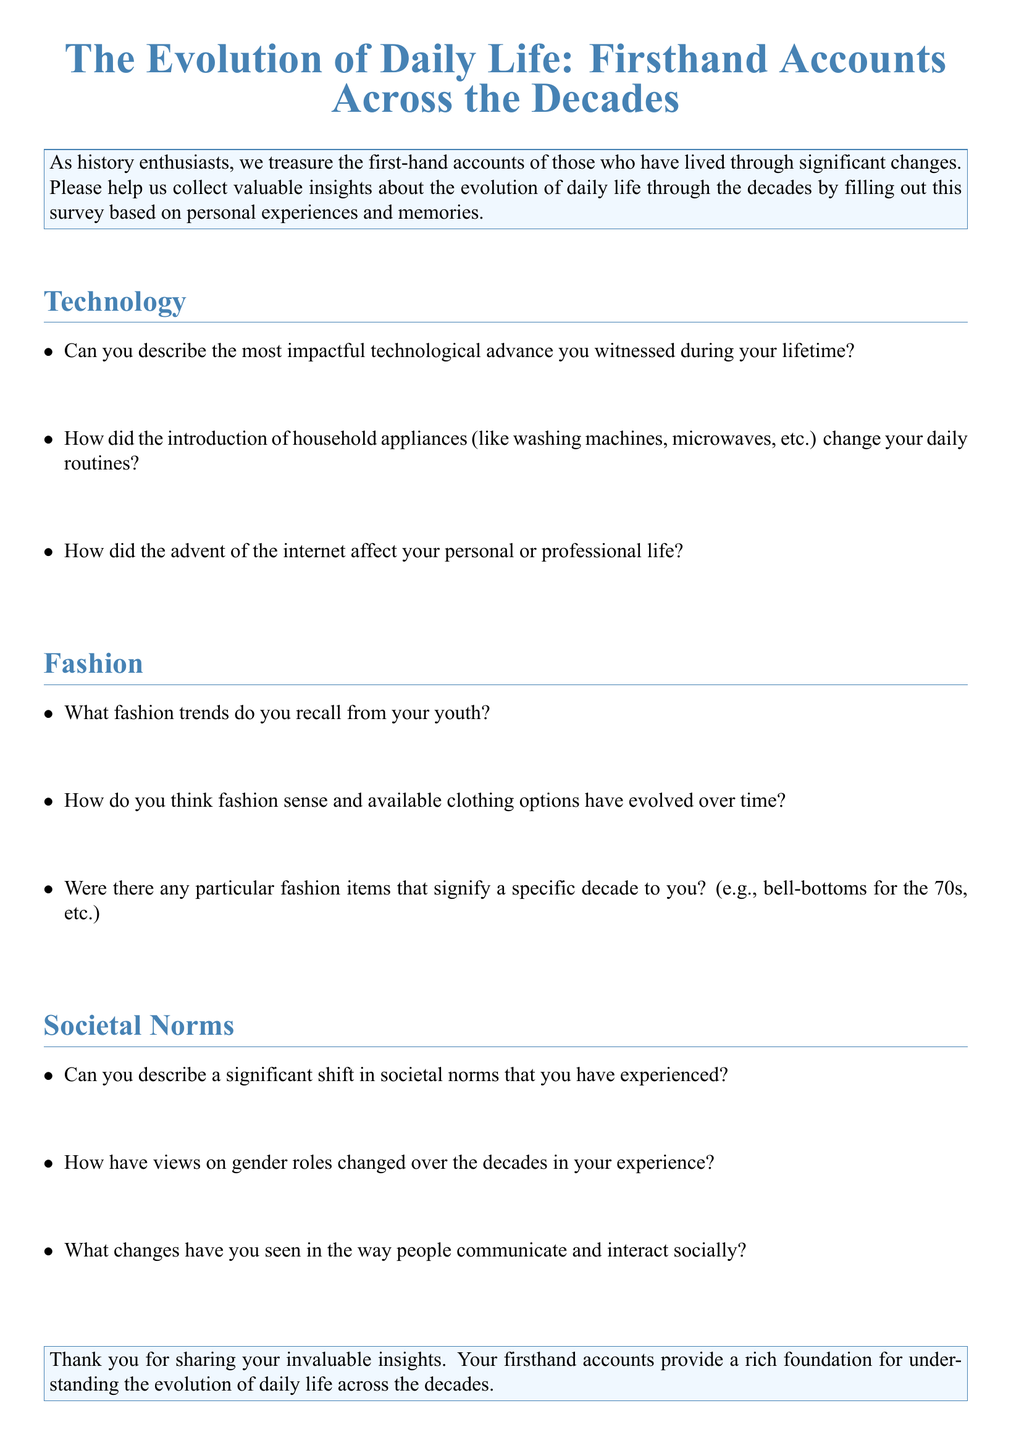Can you describe the most impactful technological advance you witnessed? This question is looking for a specific technological advance mentioned in the document.
Answer: Impactful technological advance How did the introduction of household appliances change daily routines? This question is about the effect of household appliances on daily life based on personal experiences.
Answer: Changed daily routines What fashion trends do you recall from your youth? This is asking for specific fashion trends based on the experiences shared in the document.
Answer: Fashion trends from youth Can you describe a significant shift in societal norms? This question seeks a specific example of a shift in societal norms as experienced by the respondent.
Answer: Significant shift in societal norms Were there any particular fashion items that signify a specific decade? This question looks for examples of fashion items associated with particular decades from personal memories.
Answer: Fashion items by decade 